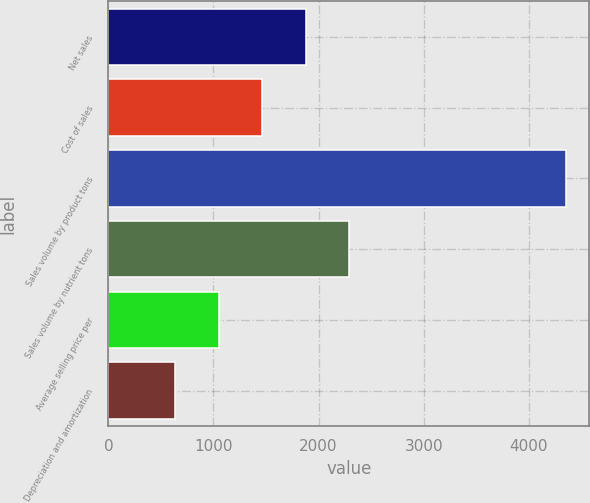Convert chart. <chart><loc_0><loc_0><loc_500><loc_500><bar_chart><fcel>Net sales<fcel>Cost of sales<fcel>Sales volume by product tons<fcel>Sales volume by nutrient tons<fcel>Average selling price per<fcel>Depreciation and amortization<nl><fcel>1876.6<fcel>1463.2<fcel>4357<fcel>2290<fcel>1049.8<fcel>636.4<nl></chart> 